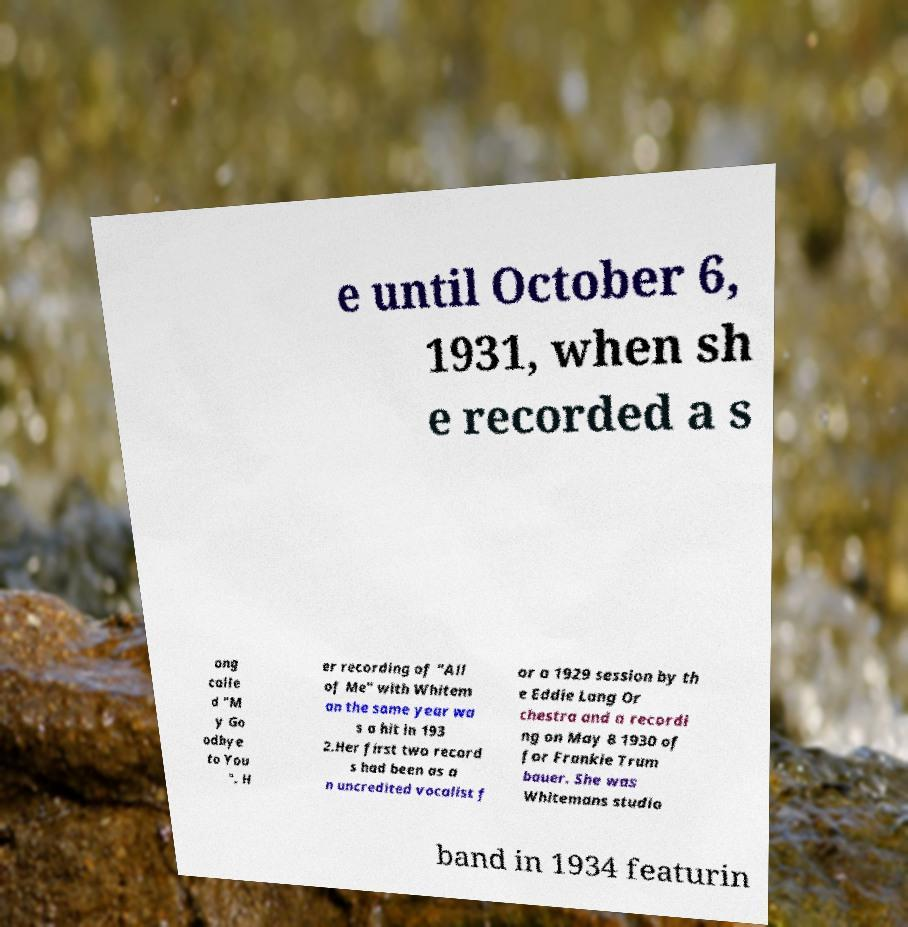Can you accurately transcribe the text from the provided image for me? e until October 6, 1931, when sh e recorded a s ong calle d "M y Go odbye to You ". H er recording of "All of Me" with Whitem an the same year wa s a hit in 193 2.Her first two record s had been as a n uncredited vocalist f or a 1929 session by th e Eddie Lang Or chestra and a recordi ng on May 8 1930 of for Frankie Trum bauer. She was Whitemans studio band in 1934 featurin 